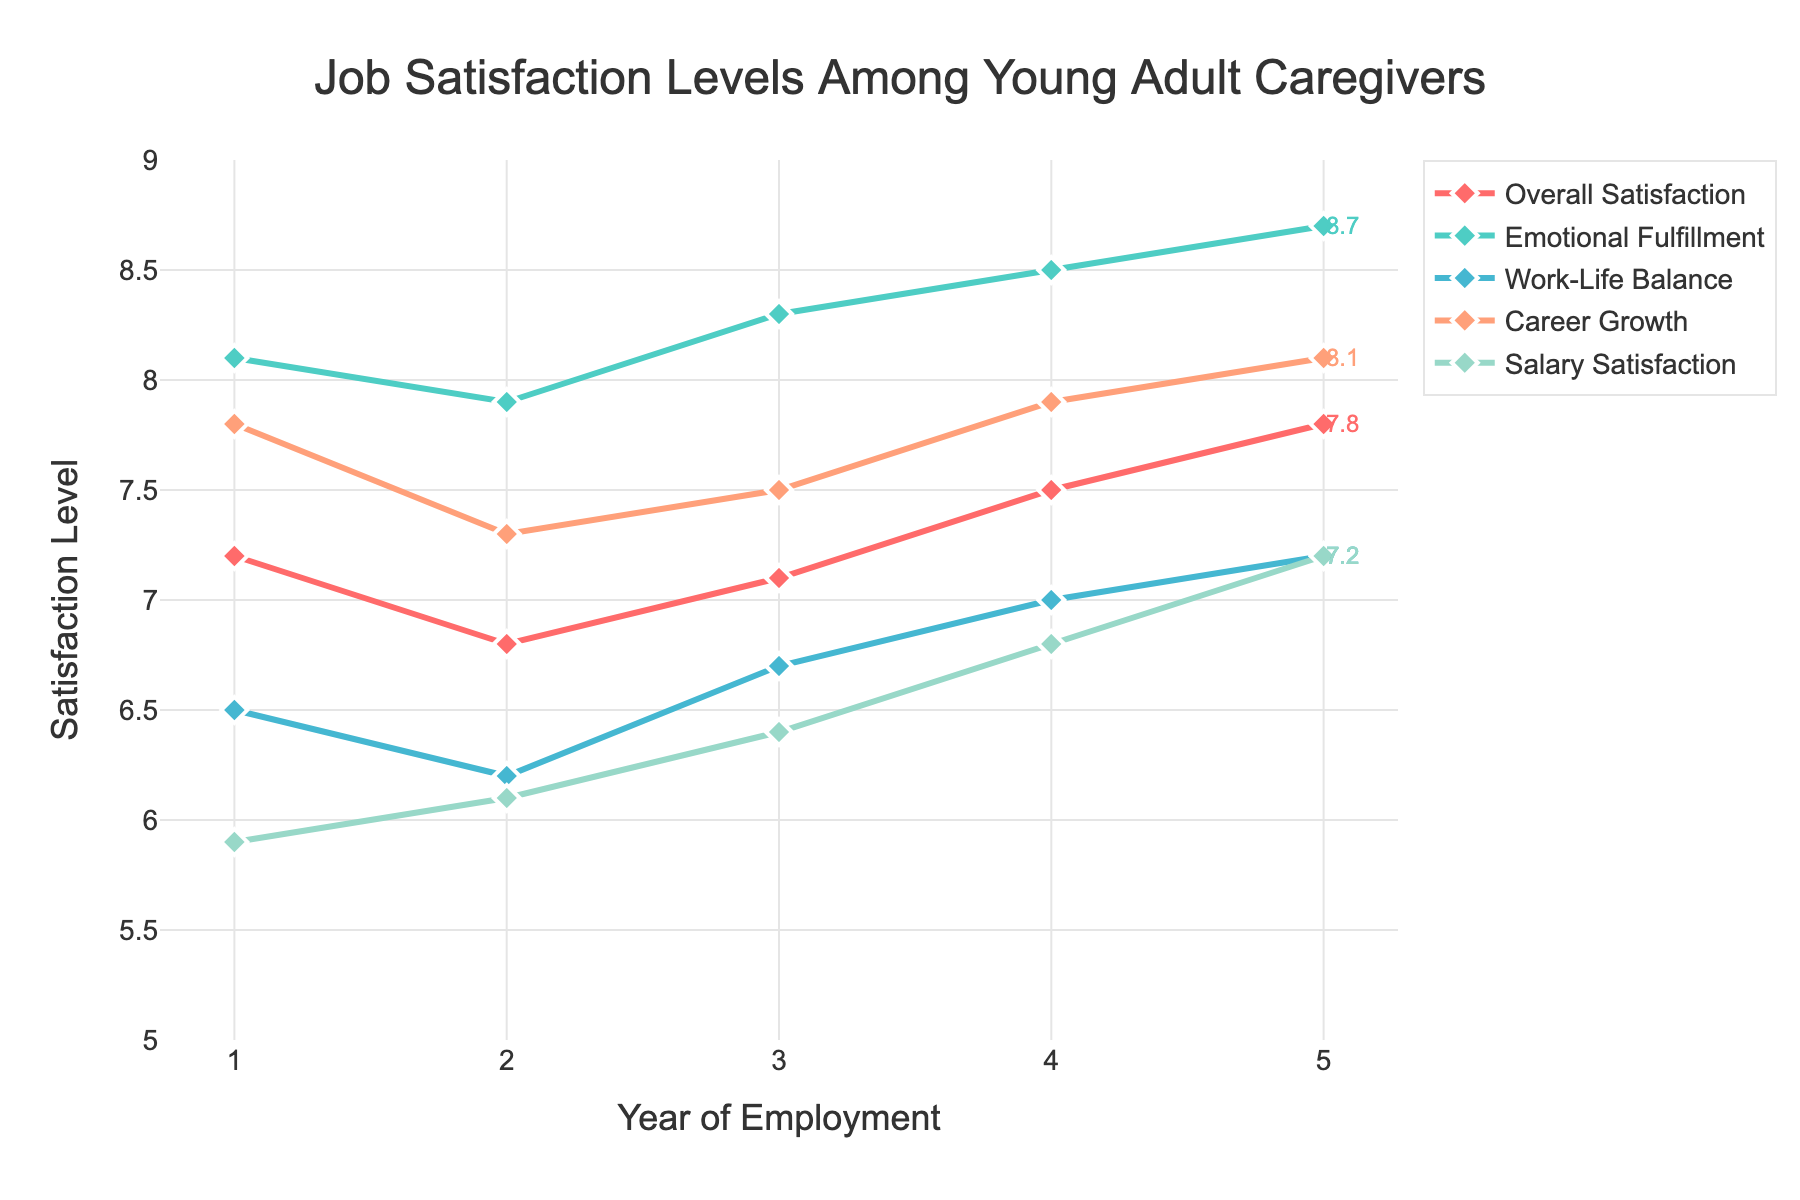What's the trend in overall job satisfaction over five years? From the figure, observe the "Overall Satisfaction" line, which increases from 7.2 in Year 1 to 7.8 in Year 5. This indicates a steady upward trend in overall job satisfaction over the five years.
Answer: Increasing trend Which satisfaction metric has the highest value in Year 5? Look at the values for each metric in Year 5. "Emotional Fulfillment" has the highest value, reaching 8.7.
Answer: Emotional Fulfillment How does Salary Satisfaction in Year 3 compare to Work-Life Balance in Year 3? From the plot, find the points for both "Salary Satisfaction" and "Work-Life Balance" in Year 3. Salary Satisfaction is at 6.4, while Work-Life Balance is at 6.7, meaning Work-Life Balance is higher.
Answer: Work-Life Balance is higher What’s the difference in "Career Growth" satisfaction between Year 1 and Year 5? Check the values for "Career Growth" in Year 1 and Year 5. In Year 1, it’s 7.8, and in Year 5, it’s 8.1. The difference is 8.1 - 7.8 = 0.3.
Answer: 0.3 What is the average Salary Satisfaction across the five years? Sum the Salary Satisfaction for each year (5.9 + 6.1 + 6.4 + 6.8 + 7.2) and divide by 5. The sum is 32.4, so the average is 32.4 / 5 = 6.48.
Answer: 6.48 Which year shows the largest improvement in Overall Satisfaction? Look at the changes in "Overall Satisfaction" between consecutive years. The largest improvement is from Year 4 (7.5) to Year 5 (7.8), with an increase of 0.3.
Answer: Year 4 to Year 5 How does Emotional Fulfillment in Year 2 compare to Salary Satisfaction in Year 3? Find both values: Emotional Fulfillment in Year 2 is 7.9, and Salary Satisfaction in Year 3 is 6.4. Emotional Fulfillment in Year 2 is higher.
Answer: Emotional Fulfillment in Year 2 is higher What is the total increase in Work-Life Balance satisfaction from Year 1 to Year 5? Subtract the value of Work-Life Balance in Year 1 from the value in Year 5: 7.2 - 6.5 = 0.7.
Answer: 0.7 What’s the highest recorded value for any metric in the figure? Look at the highest points for all metrics. The highest value is 8.7 for Emotional Fulfillment in Year 5.
Answer: 8.7 Which metric saw the most significant increase over the five years? Compare the changes for each metric from Year 1 to Year 5. "Salary Satisfaction" increased from 5.9 to 7.2, a change of 1.3, which is the largest increase among all metrics.
Answer: Salary Satisfaction 